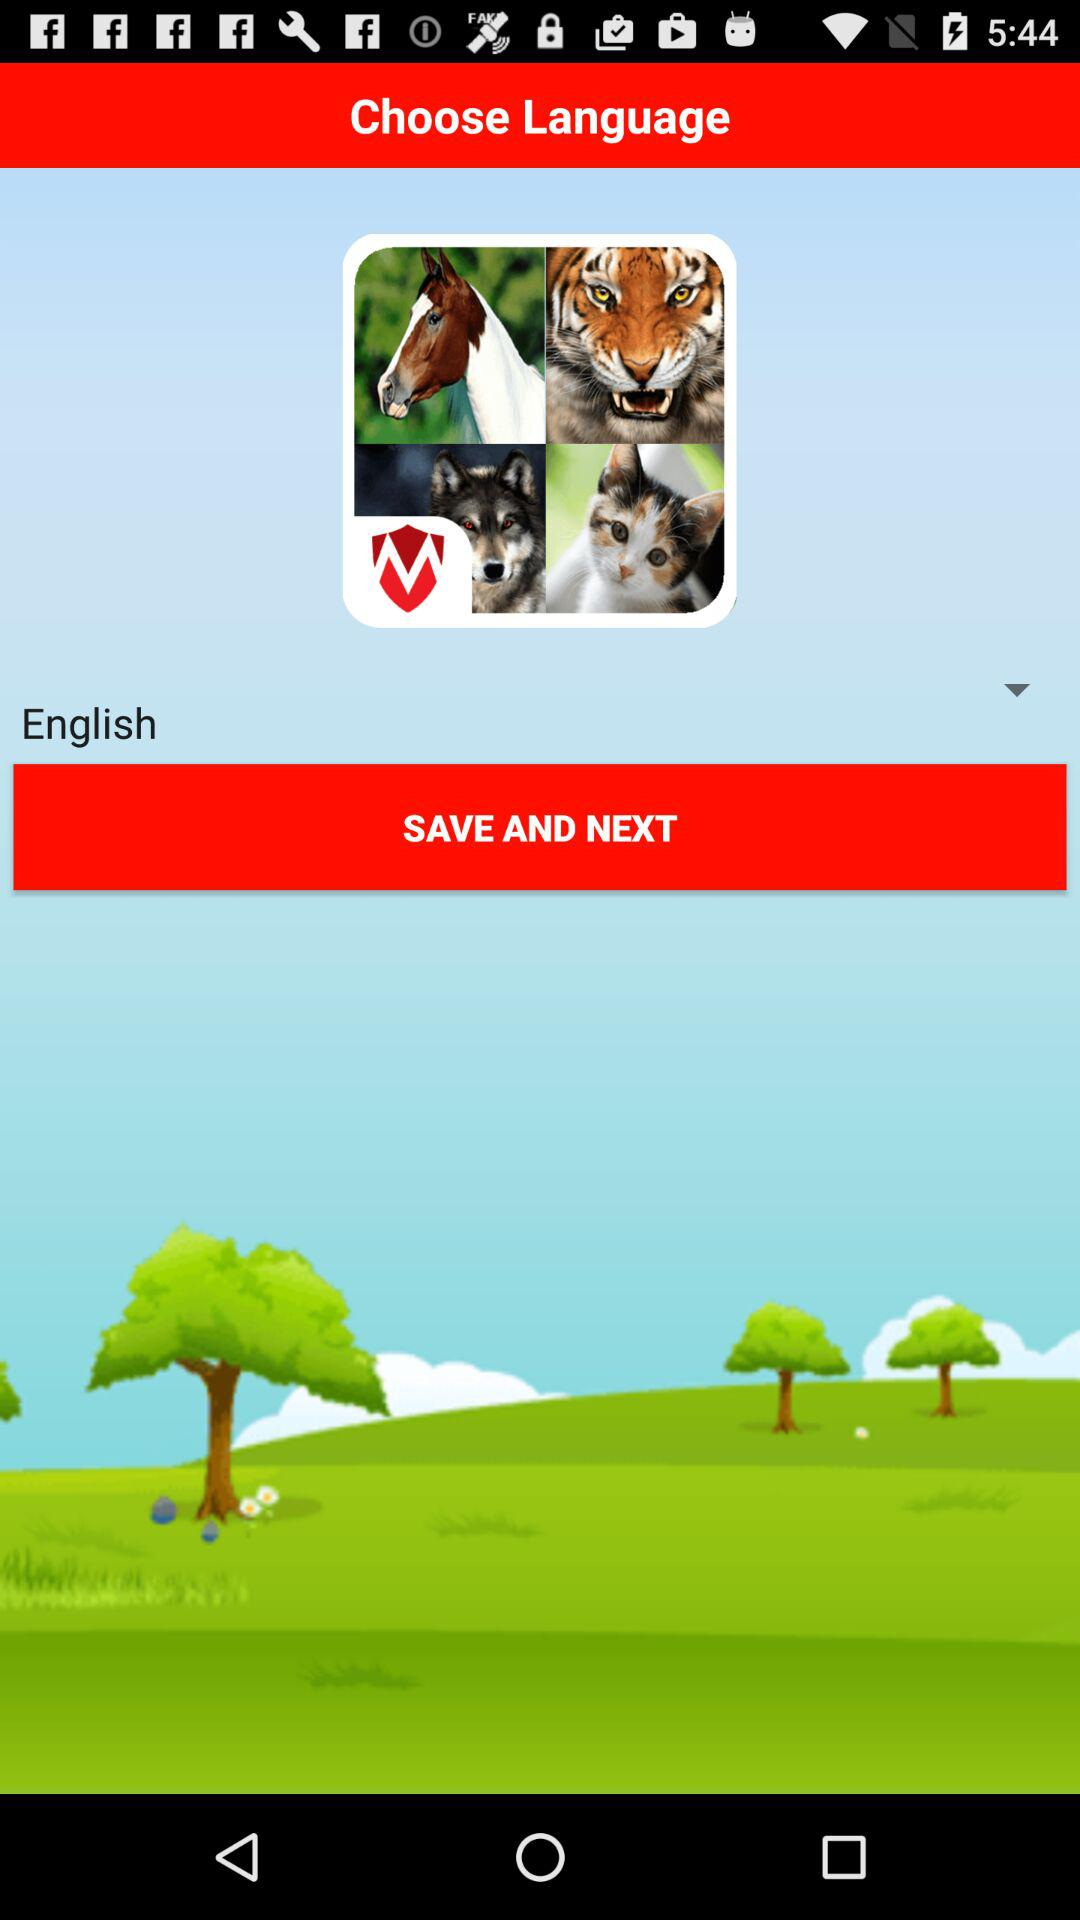What is the selected language? The selected language is English. 